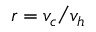<formula> <loc_0><loc_0><loc_500><loc_500>r = v _ { c } v _ { h }</formula> 